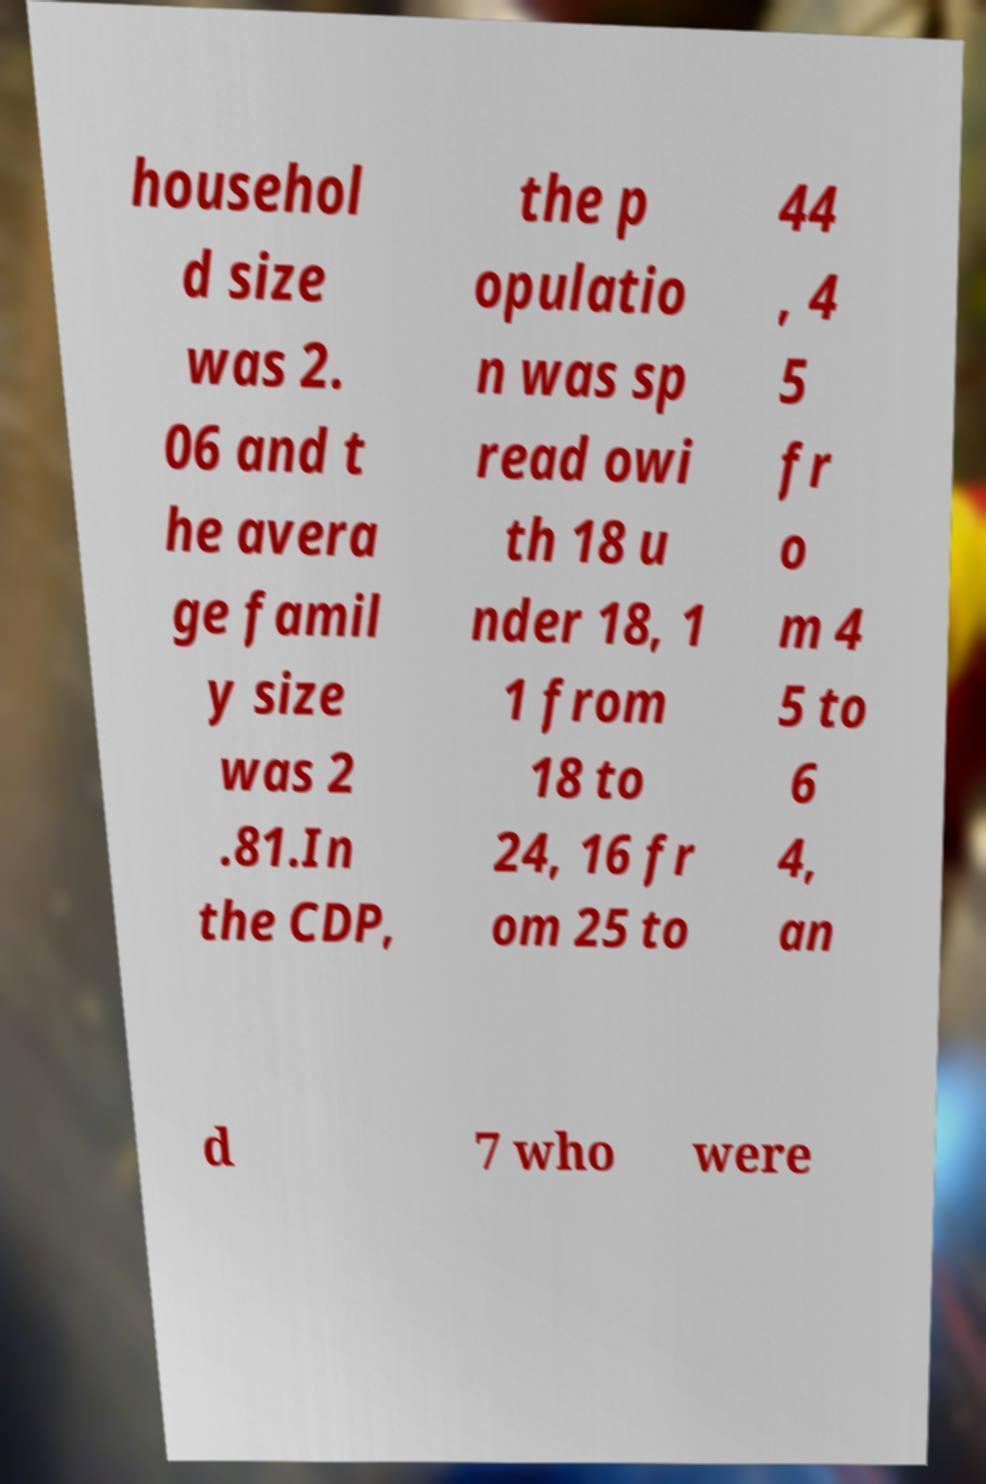I need the written content from this picture converted into text. Can you do that? househol d size was 2. 06 and t he avera ge famil y size was 2 .81.In the CDP, the p opulatio n was sp read owi th 18 u nder 18, 1 1 from 18 to 24, 16 fr om 25 to 44 , 4 5 fr o m 4 5 to 6 4, an d 7 who were 